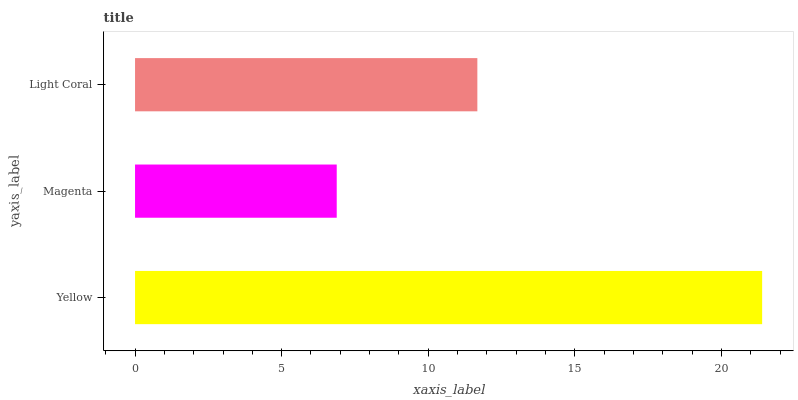Is Magenta the minimum?
Answer yes or no. Yes. Is Yellow the maximum?
Answer yes or no. Yes. Is Light Coral the minimum?
Answer yes or no. No. Is Light Coral the maximum?
Answer yes or no. No. Is Light Coral greater than Magenta?
Answer yes or no. Yes. Is Magenta less than Light Coral?
Answer yes or no. Yes. Is Magenta greater than Light Coral?
Answer yes or no. No. Is Light Coral less than Magenta?
Answer yes or no. No. Is Light Coral the high median?
Answer yes or no. Yes. Is Light Coral the low median?
Answer yes or no. Yes. Is Yellow the high median?
Answer yes or no. No. Is Magenta the low median?
Answer yes or no. No. 